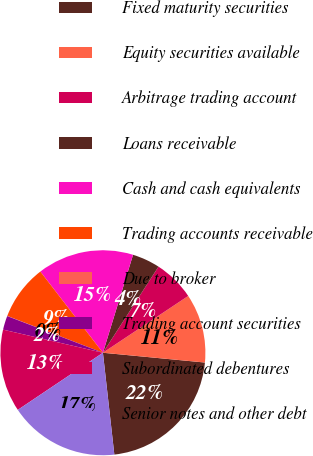Convert chart to OTSL. <chart><loc_0><loc_0><loc_500><loc_500><pie_chart><fcel>Fixed maturity securities<fcel>Equity securities available<fcel>Arbitrage trading account<fcel>Loans receivable<fcel>Cash and cash equivalents<fcel>Trading accounts receivable<fcel>Due to broker<fcel>Trading account securities<fcel>Subordinated debentures<fcel>Senior notes and other debt<nl><fcel>21.7%<fcel>10.87%<fcel>6.53%<fcel>4.37%<fcel>15.2%<fcel>8.7%<fcel>0.03%<fcel>2.2%<fcel>13.03%<fcel>17.37%<nl></chart> 